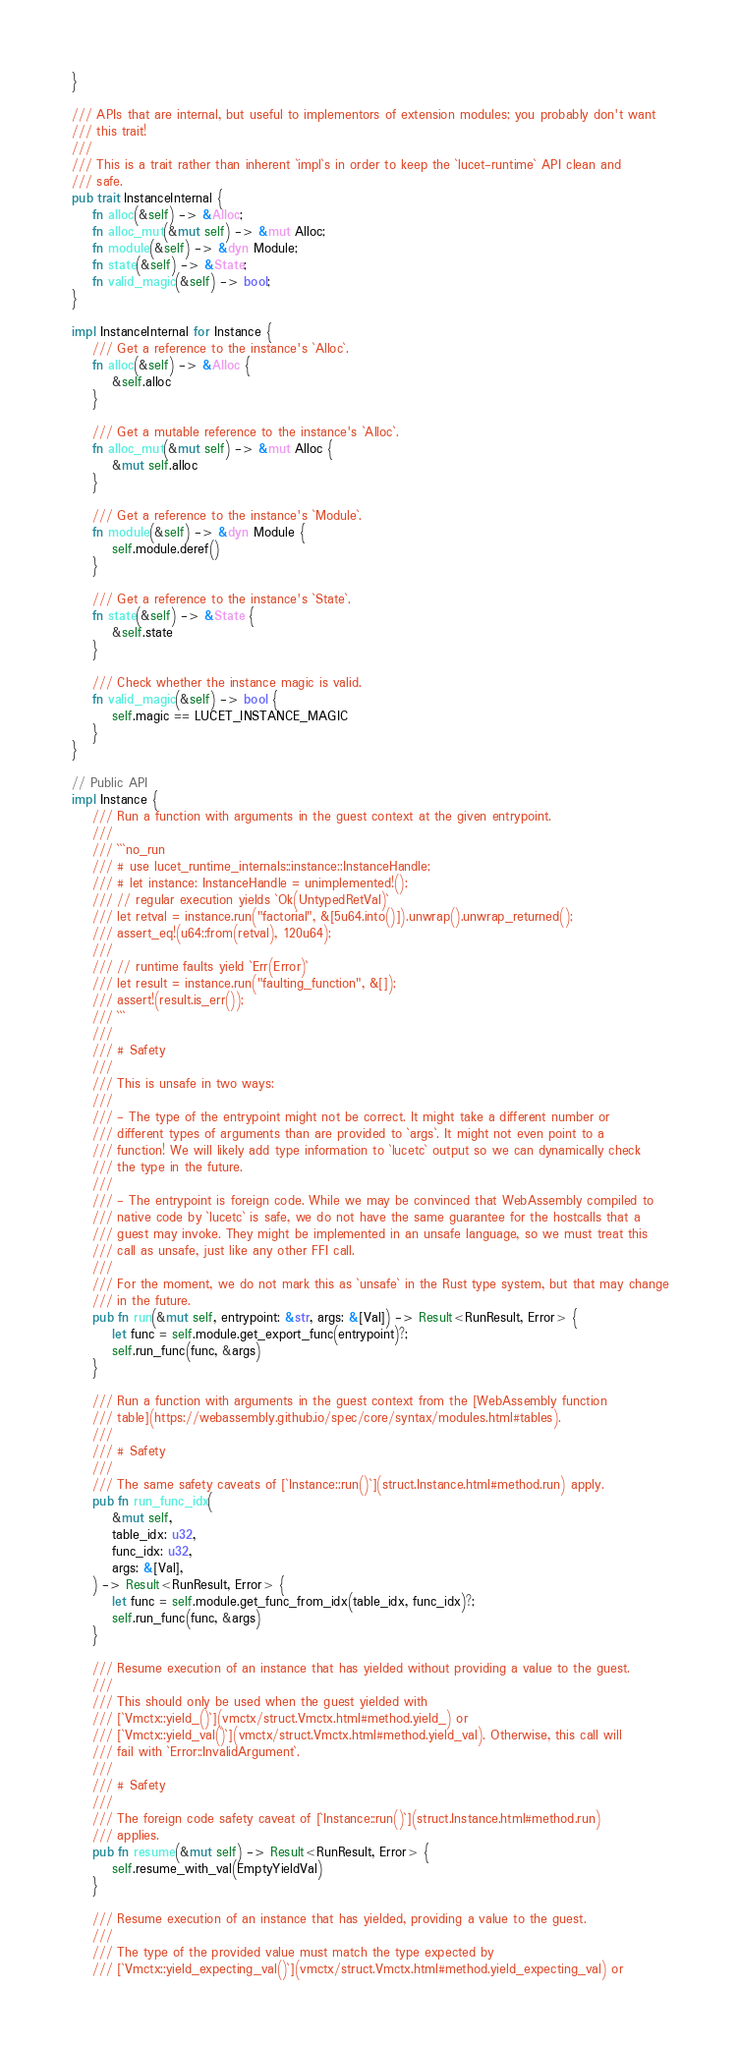<code> <loc_0><loc_0><loc_500><loc_500><_Rust_>}

/// APIs that are internal, but useful to implementors of extension modules; you probably don't want
/// this trait!
///
/// This is a trait rather than inherent `impl`s in order to keep the `lucet-runtime` API clean and
/// safe.
pub trait InstanceInternal {
    fn alloc(&self) -> &Alloc;
    fn alloc_mut(&mut self) -> &mut Alloc;
    fn module(&self) -> &dyn Module;
    fn state(&self) -> &State;
    fn valid_magic(&self) -> bool;
}

impl InstanceInternal for Instance {
    /// Get a reference to the instance's `Alloc`.
    fn alloc(&self) -> &Alloc {
        &self.alloc
    }

    /// Get a mutable reference to the instance's `Alloc`.
    fn alloc_mut(&mut self) -> &mut Alloc {
        &mut self.alloc
    }

    /// Get a reference to the instance's `Module`.
    fn module(&self) -> &dyn Module {
        self.module.deref()
    }

    /// Get a reference to the instance's `State`.
    fn state(&self) -> &State {
        &self.state
    }

    /// Check whether the instance magic is valid.
    fn valid_magic(&self) -> bool {
        self.magic == LUCET_INSTANCE_MAGIC
    }
}

// Public API
impl Instance {
    /// Run a function with arguments in the guest context at the given entrypoint.
    ///
    /// ```no_run
    /// # use lucet_runtime_internals::instance::InstanceHandle;
    /// # let instance: InstanceHandle = unimplemented!();
    /// // regular execution yields `Ok(UntypedRetVal)`
    /// let retval = instance.run("factorial", &[5u64.into()]).unwrap().unwrap_returned();
    /// assert_eq!(u64::from(retval), 120u64);
    ///
    /// // runtime faults yield `Err(Error)`
    /// let result = instance.run("faulting_function", &[]);
    /// assert!(result.is_err());
    /// ```
    ///
    /// # Safety
    ///
    /// This is unsafe in two ways:
    ///
    /// - The type of the entrypoint might not be correct. It might take a different number or
    /// different types of arguments than are provided to `args`. It might not even point to a
    /// function! We will likely add type information to `lucetc` output so we can dynamically check
    /// the type in the future.
    ///
    /// - The entrypoint is foreign code. While we may be convinced that WebAssembly compiled to
    /// native code by `lucetc` is safe, we do not have the same guarantee for the hostcalls that a
    /// guest may invoke. They might be implemented in an unsafe language, so we must treat this
    /// call as unsafe, just like any other FFI call.
    ///
    /// For the moment, we do not mark this as `unsafe` in the Rust type system, but that may change
    /// in the future.
    pub fn run(&mut self, entrypoint: &str, args: &[Val]) -> Result<RunResult, Error> {
        let func = self.module.get_export_func(entrypoint)?;
        self.run_func(func, &args)
    }

    /// Run a function with arguments in the guest context from the [WebAssembly function
    /// table](https://webassembly.github.io/spec/core/syntax/modules.html#tables).
    ///
    /// # Safety
    ///
    /// The same safety caveats of [`Instance::run()`](struct.Instance.html#method.run) apply.
    pub fn run_func_idx(
        &mut self,
        table_idx: u32,
        func_idx: u32,
        args: &[Val],
    ) -> Result<RunResult, Error> {
        let func = self.module.get_func_from_idx(table_idx, func_idx)?;
        self.run_func(func, &args)
    }

    /// Resume execution of an instance that has yielded without providing a value to the guest.
    ///
    /// This should only be used when the guest yielded with
    /// [`Vmctx::yield_()`](vmctx/struct.Vmctx.html#method.yield_) or
    /// [`Vmctx::yield_val()`](vmctx/struct.Vmctx.html#method.yield_val). Otherwise, this call will
    /// fail with `Error::InvalidArgument`.
    ///
    /// # Safety
    ///
    /// The foreign code safety caveat of [`Instance::run()`](struct.Instance.html#method.run)
    /// applies.
    pub fn resume(&mut self) -> Result<RunResult, Error> {
        self.resume_with_val(EmptyYieldVal)
    }

    /// Resume execution of an instance that has yielded, providing a value to the guest.
    ///
    /// The type of the provided value must match the type expected by
    /// [`Vmctx::yield_expecting_val()`](vmctx/struct.Vmctx.html#method.yield_expecting_val) or</code> 